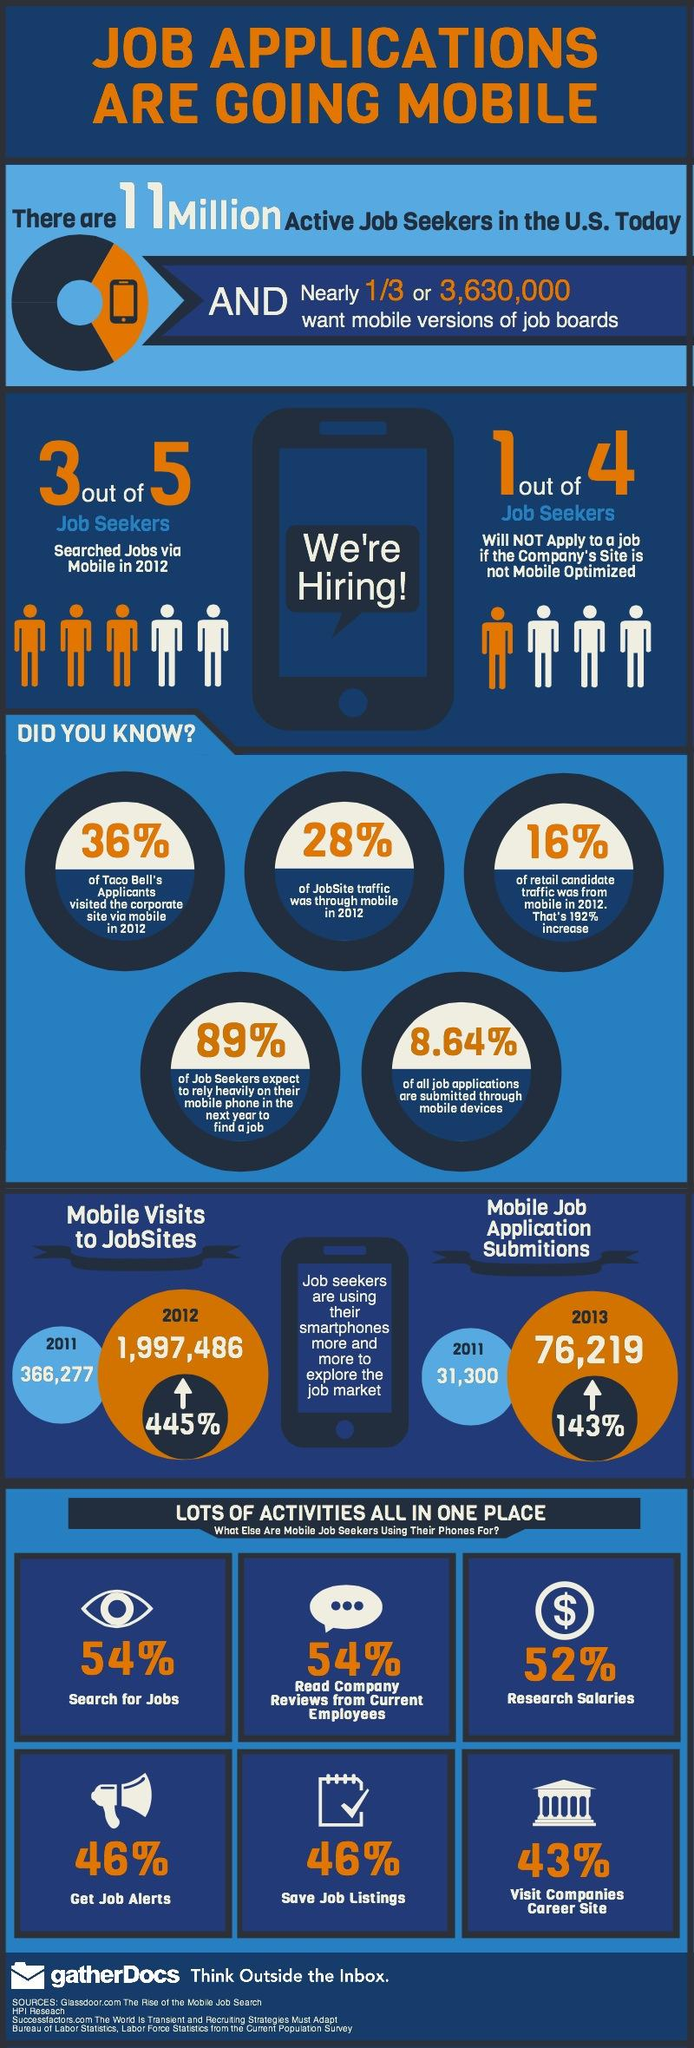Specify some key components in this picture. In 2012, the percentage of mobile traffic on Jobsite was 28%. According to Taco Bell's applicant data, 36% of visitors to their website came from mobile devices. According to the study, 43% of mobile job seekers used their phones to visit companies' career sites. The percentage increase in mobile visits to jobsites was 445%. In 2012, approximately 60% of job seekers used mobile devices to look for employment opportunities. 